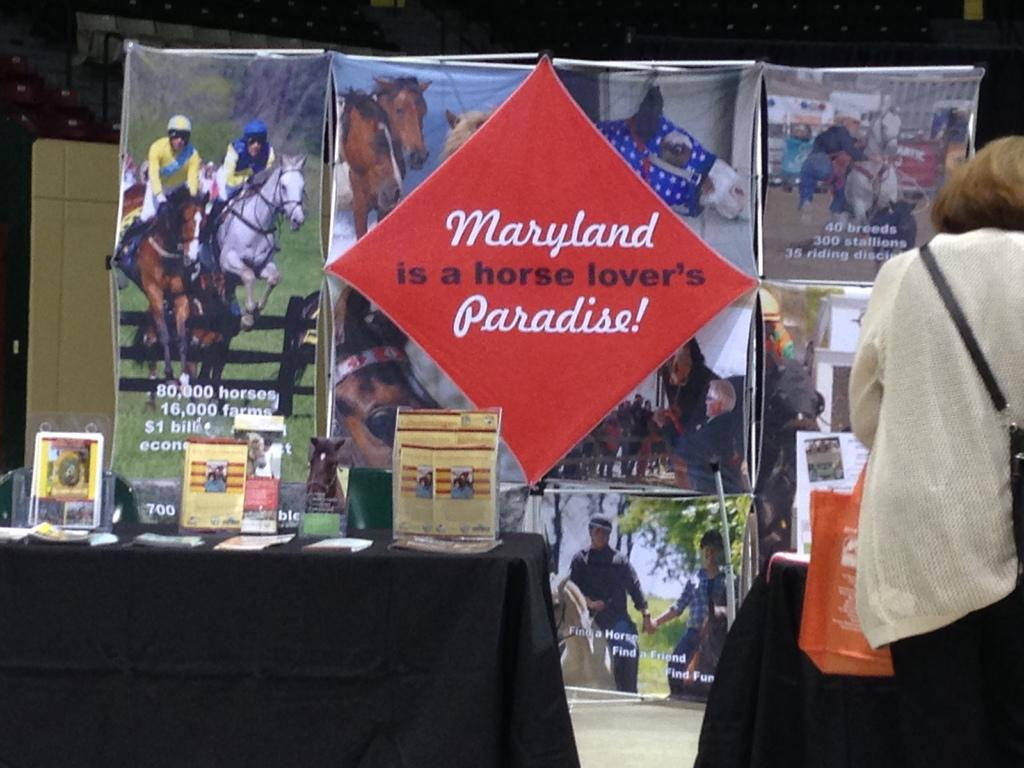<image>
Describe the image concisely. Diamond shaped sign that says "Maryland is a horse lover's Paradise". 